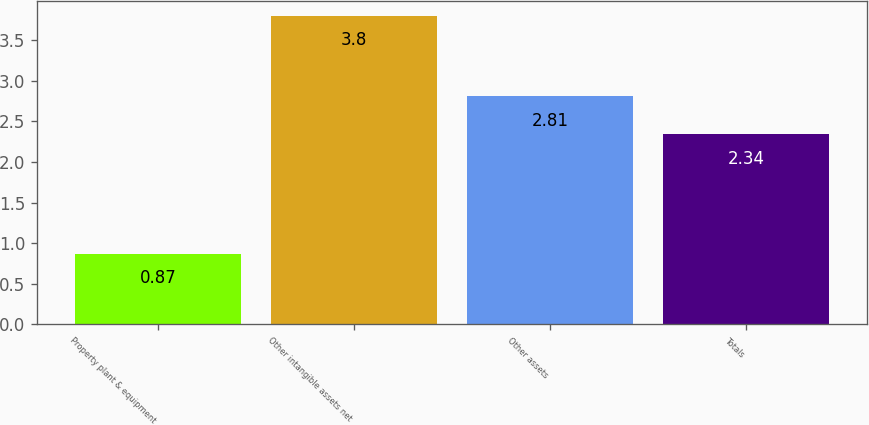<chart> <loc_0><loc_0><loc_500><loc_500><bar_chart><fcel>Property plant & equipment<fcel>Other intangible assets net<fcel>Other assets<fcel>Totals<nl><fcel>0.87<fcel>3.8<fcel>2.81<fcel>2.34<nl></chart> 